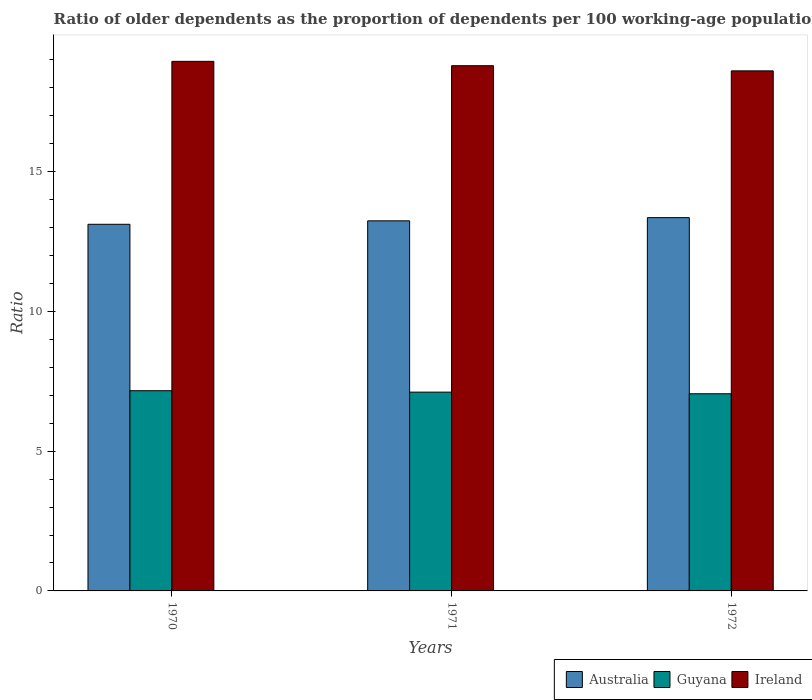How many different coloured bars are there?
Offer a very short reply. 3. Are the number of bars on each tick of the X-axis equal?
Provide a short and direct response. Yes. In how many cases, is the number of bars for a given year not equal to the number of legend labels?
Make the answer very short. 0. What is the age dependency ratio(old) in Australia in 1970?
Offer a terse response. 13.12. Across all years, what is the maximum age dependency ratio(old) in Australia?
Provide a short and direct response. 13.36. Across all years, what is the minimum age dependency ratio(old) in Australia?
Your answer should be very brief. 13.12. In which year was the age dependency ratio(old) in Ireland maximum?
Give a very brief answer. 1970. In which year was the age dependency ratio(old) in Ireland minimum?
Give a very brief answer. 1972. What is the total age dependency ratio(old) in Ireland in the graph?
Offer a terse response. 56.35. What is the difference between the age dependency ratio(old) in Ireland in 1971 and that in 1972?
Ensure brevity in your answer.  0.18. What is the difference between the age dependency ratio(old) in Ireland in 1970 and the age dependency ratio(old) in Guyana in 1971?
Ensure brevity in your answer.  11.84. What is the average age dependency ratio(old) in Ireland per year?
Your answer should be compact. 18.78. In the year 1972, what is the difference between the age dependency ratio(old) in Guyana and age dependency ratio(old) in Ireland?
Ensure brevity in your answer.  -11.55. What is the ratio of the age dependency ratio(old) in Australia in 1970 to that in 1972?
Provide a succinct answer. 0.98. Is the age dependency ratio(old) in Ireland in 1970 less than that in 1971?
Provide a short and direct response. No. What is the difference between the highest and the second highest age dependency ratio(old) in Guyana?
Your response must be concise. 0.05. What is the difference between the highest and the lowest age dependency ratio(old) in Australia?
Your response must be concise. 0.24. Is the sum of the age dependency ratio(old) in Guyana in 1971 and 1972 greater than the maximum age dependency ratio(old) in Australia across all years?
Your response must be concise. Yes. What does the 1st bar from the left in 1972 represents?
Your answer should be very brief. Australia. What does the 1st bar from the right in 1972 represents?
Give a very brief answer. Ireland. How many bars are there?
Provide a short and direct response. 9. Does the graph contain grids?
Provide a short and direct response. No. Where does the legend appear in the graph?
Offer a terse response. Bottom right. What is the title of the graph?
Offer a very short reply. Ratio of older dependents as the proportion of dependents per 100 working-age population. Does "Mauritius" appear as one of the legend labels in the graph?
Your answer should be compact. No. What is the label or title of the X-axis?
Your response must be concise. Years. What is the label or title of the Y-axis?
Make the answer very short. Ratio. What is the Ratio in Australia in 1970?
Give a very brief answer. 13.12. What is the Ratio in Guyana in 1970?
Provide a succinct answer. 7.16. What is the Ratio in Ireland in 1970?
Offer a very short reply. 18.95. What is the Ratio in Australia in 1971?
Ensure brevity in your answer.  13.24. What is the Ratio in Guyana in 1971?
Make the answer very short. 7.11. What is the Ratio of Ireland in 1971?
Make the answer very short. 18.79. What is the Ratio of Australia in 1972?
Give a very brief answer. 13.36. What is the Ratio in Guyana in 1972?
Provide a succinct answer. 7.05. What is the Ratio in Ireland in 1972?
Your answer should be compact. 18.61. Across all years, what is the maximum Ratio of Australia?
Your answer should be very brief. 13.36. Across all years, what is the maximum Ratio of Guyana?
Provide a succinct answer. 7.16. Across all years, what is the maximum Ratio in Ireland?
Provide a short and direct response. 18.95. Across all years, what is the minimum Ratio in Australia?
Ensure brevity in your answer.  13.12. Across all years, what is the minimum Ratio of Guyana?
Your response must be concise. 7.05. Across all years, what is the minimum Ratio in Ireland?
Ensure brevity in your answer.  18.61. What is the total Ratio of Australia in the graph?
Your answer should be very brief. 39.72. What is the total Ratio of Guyana in the graph?
Your response must be concise. 21.33. What is the total Ratio of Ireland in the graph?
Your response must be concise. 56.35. What is the difference between the Ratio in Australia in 1970 and that in 1971?
Give a very brief answer. -0.12. What is the difference between the Ratio of Guyana in 1970 and that in 1971?
Provide a succinct answer. 0.05. What is the difference between the Ratio in Ireland in 1970 and that in 1971?
Give a very brief answer. 0.16. What is the difference between the Ratio of Australia in 1970 and that in 1972?
Give a very brief answer. -0.24. What is the difference between the Ratio of Guyana in 1970 and that in 1972?
Your answer should be very brief. 0.11. What is the difference between the Ratio of Ireland in 1970 and that in 1972?
Provide a short and direct response. 0.34. What is the difference between the Ratio of Australia in 1971 and that in 1972?
Offer a very short reply. -0.11. What is the difference between the Ratio in Guyana in 1971 and that in 1972?
Your answer should be compact. 0.06. What is the difference between the Ratio in Ireland in 1971 and that in 1972?
Your answer should be compact. 0.18. What is the difference between the Ratio of Australia in 1970 and the Ratio of Guyana in 1971?
Keep it short and to the point. 6.01. What is the difference between the Ratio in Australia in 1970 and the Ratio in Ireland in 1971?
Your answer should be very brief. -5.67. What is the difference between the Ratio in Guyana in 1970 and the Ratio in Ireland in 1971?
Offer a very short reply. -11.63. What is the difference between the Ratio of Australia in 1970 and the Ratio of Guyana in 1972?
Give a very brief answer. 6.06. What is the difference between the Ratio of Australia in 1970 and the Ratio of Ireland in 1972?
Your answer should be compact. -5.49. What is the difference between the Ratio of Guyana in 1970 and the Ratio of Ireland in 1972?
Keep it short and to the point. -11.44. What is the difference between the Ratio of Australia in 1971 and the Ratio of Guyana in 1972?
Provide a short and direct response. 6.19. What is the difference between the Ratio of Australia in 1971 and the Ratio of Ireland in 1972?
Provide a short and direct response. -5.37. What is the difference between the Ratio of Guyana in 1971 and the Ratio of Ireland in 1972?
Keep it short and to the point. -11.49. What is the average Ratio in Australia per year?
Give a very brief answer. 13.24. What is the average Ratio of Guyana per year?
Make the answer very short. 7.11. What is the average Ratio in Ireland per year?
Give a very brief answer. 18.78. In the year 1970, what is the difference between the Ratio of Australia and Ratio of Guyana?
Your answer should be very brief. 5.95. In the year 1970, what is the difference between the Ratio in Australia and Ratio in Ireland?
Give a very brief answer. -5.83. In the year 1970, what is the difference between the Ratio in Guyana and Ratio in Ireland?
Give a very brief answer. -11.78. In the year 1971, what is the difference between the Ratio in Australia and Ratio in Guyana?
Your answer should be compact. 6.13. In the year 1971, what is the difference between the Ratio in Australia and Ratio in Ireland?
Offer a very short reply. -5.55. In the year 1971, what is the difference between the Ratio in Guyana and Ratio in Ireland?
Provide a succinct answer. -11.68. In the year 1972, what is the difference between the Ratio of Australia and Ratio of Guyana?
Keep it short and to the point. 6.3. In the year 1972, what is the difference between the Ratio in Australia and Ratio in Ireland?
Offer a terse response. -5.25. In the year 1972, what is the difference between the Ratio of Guyana and Ratio of Ireland?
Offer a very short reply. -11.55. What is the ratio of the Ratio of Australia in 1970 to that in 1971?
Give a very brief answer. 0.99. What is the ratio of the Ratio in Ireland in 1970 to that in 1971?
Your answer should be very brief. 1.01. What is the ratio of the Ratio in Australia in 1970 to that in 1972?
Offer a terse response. 0.98. What is the ratio of the Ratio of Guyana in 1970 to that in 1972?
Your response must be concise. 1.02. What is the ratio of the Ratio in Ireland in 1970 to that in 1972?
Provide a short and direct response. 1.02. What is the ratio of the Ratio in Australia in 1971 to that in 1972?
Provide a succinct answer. 0.99. What is the ratio of the Ratio in Guyana in 1971 to that in 1972?
Make the answer very short. 1.01. What is the ratio of the Ratio in Ireland in 1971 to that in 1972?
Give a very brief answer. 1.01. What is the difference between the highest and the second highest Ratio of Australia?
Ensure brevity in your answer.  0.11. What is the difference between the highest and the second highest Ratio of Guyana?
Offer a terse response. 0.05. What is the difference between the highest and the second highest Ratio in Ireland?
Offer a terse response. 0.16. What is the difference between the highest and the lowest Ratio of Australia?
Make the answer very short. 0.24. What is the difference between the highest and the lowest Ratio in Guyana?
Provide a succinct answer. 0.11. What is the difference between the highest and the lowest Ratio in Ireland?
Provide a succinct answer. 0.34. 